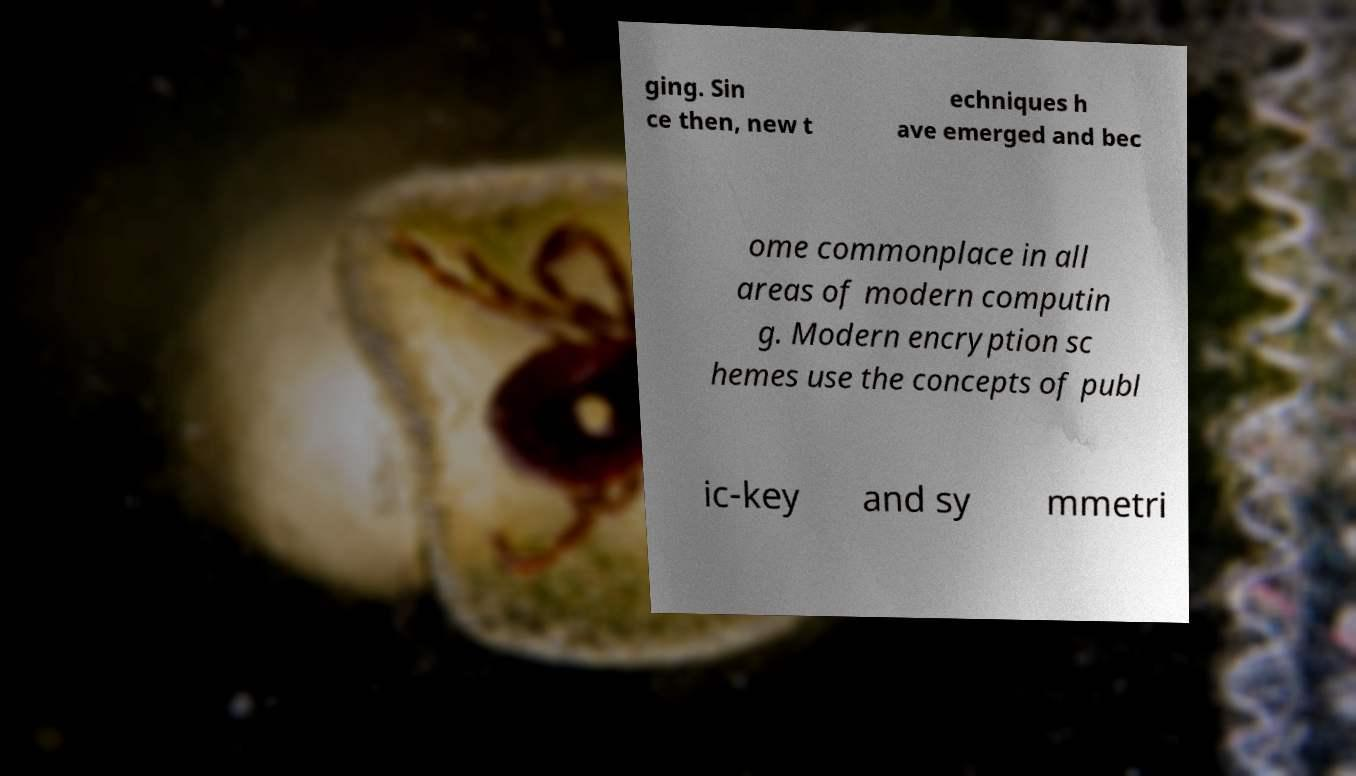What messages or text are displayed in this image? I need them in a readable, typed format. ging. Sin ce then, new t echniques h ave emerged and bec ome commonplace in all areas of modern computin g. Modern encryption sc hemes use the concepts of publ ic-key and sy mmetri 